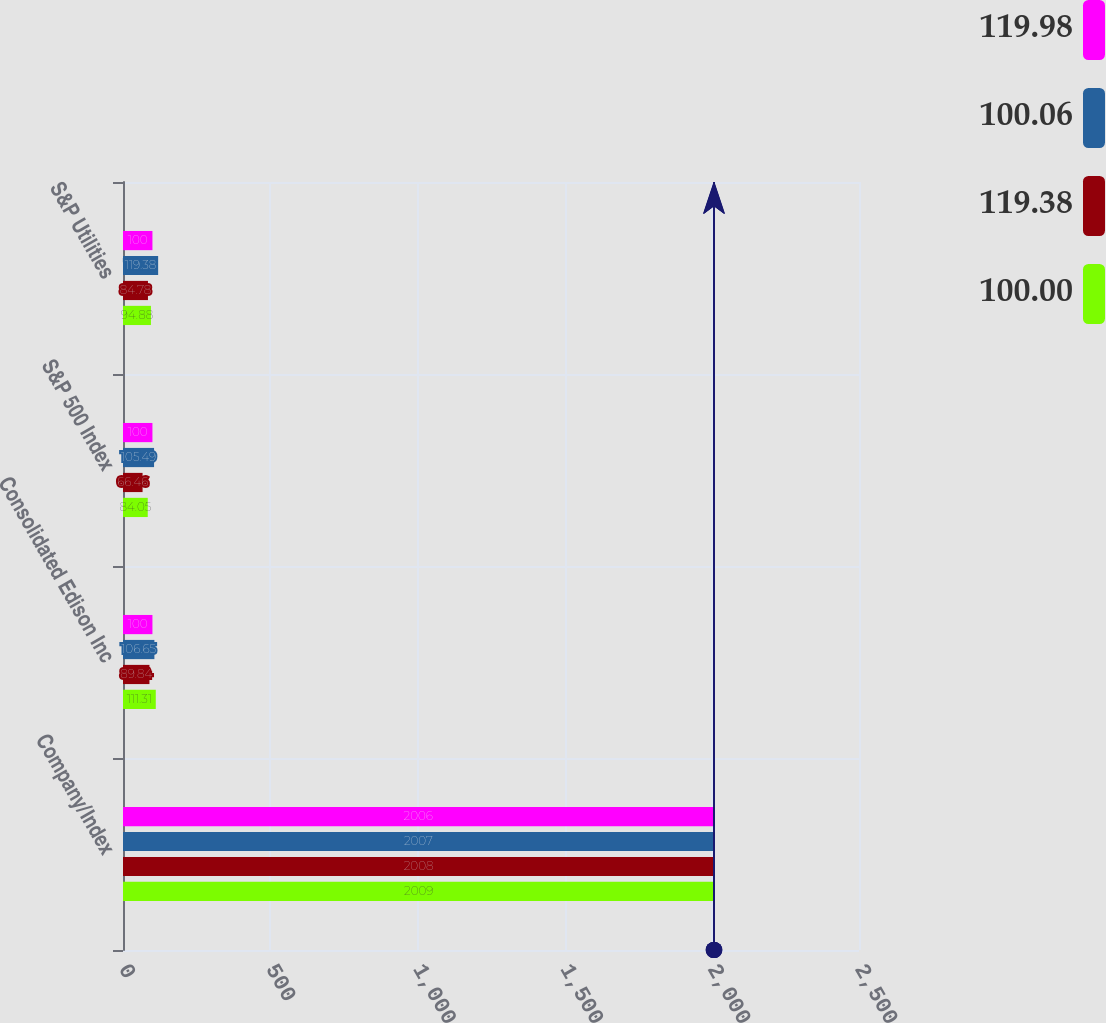Convert chart to OTSL. <chart><loc_0><loc_0><loc_500><loc_500><stacked_bar_chart><ecel><fcel>Company/Index<fcel>Consolidated Edison Inc<fcel>S&P 500 Index<fcel>S&P Utilities<nl><fcel>119.98<fcel>2006<fcel>100<fcel>100<fcel>100<nl><fcel>100.06<fcel>2007<fcel>106.65<fcel>105.49<fcel>119.38<nl><fcel>119.38<fcel>2008<fcel>89.84<fcel>66.46<fcel>84.78<nl><fcel>100<fcel>2009<fcel>111.31<fcel>84.05<fcel>94.88<nl></chart> 